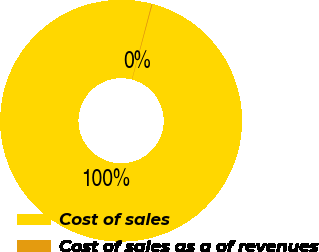<chart> <loc_0><loc_0><loc_500><loc_500><pie_chart><fcel>Cost of sales<fcel>Cost of sales as a of revenues<nl><fcel>99.89%<fcel>0.11%<nl></chart> 